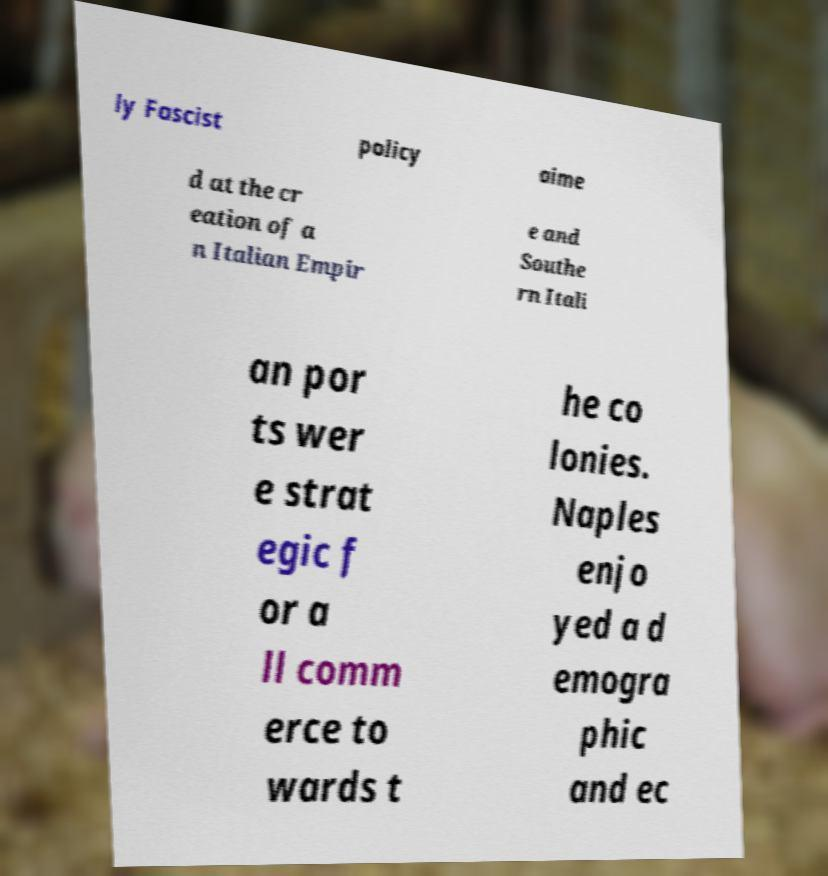Could you assist in decoding the text presented in this image and type it out clearly? ly Fascist policy aime d at the cr eation of a n Italian Empir e and Southe rn Itali an por ts wer e strat egic f or a ll comm erce to wards t he co lonies. Naples enjo yed a d emogra phic and ec 